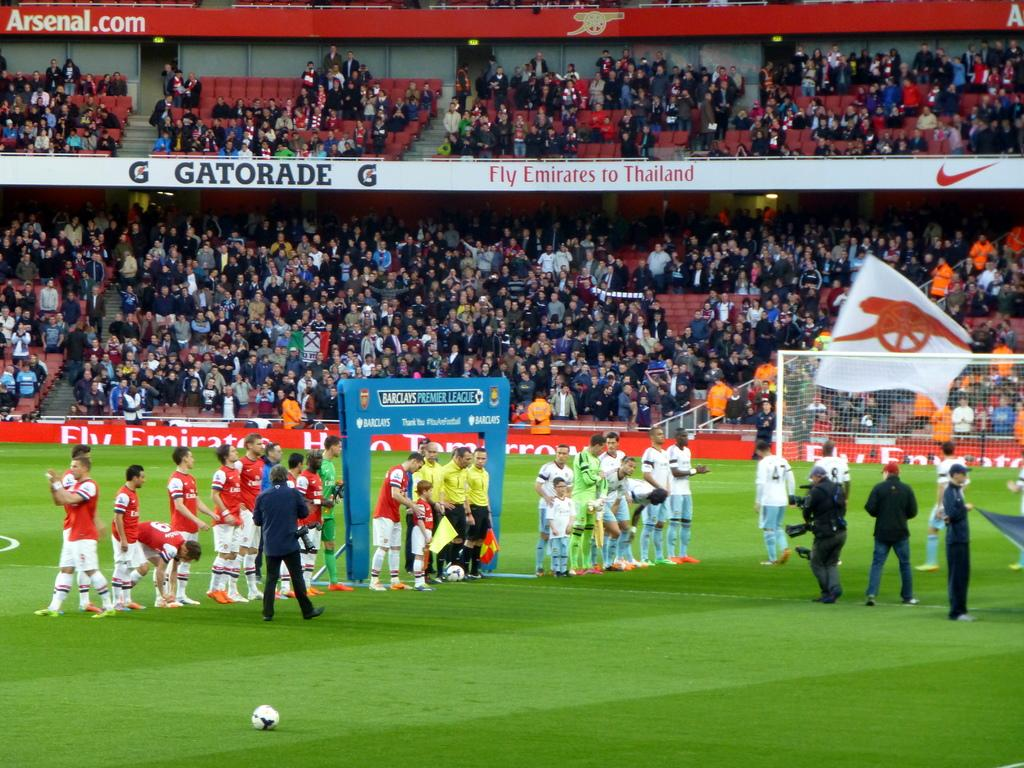<image>
Give a short and clear explanation of the subsequent image. players on field with banners from Gatorade and Emirate behind them 